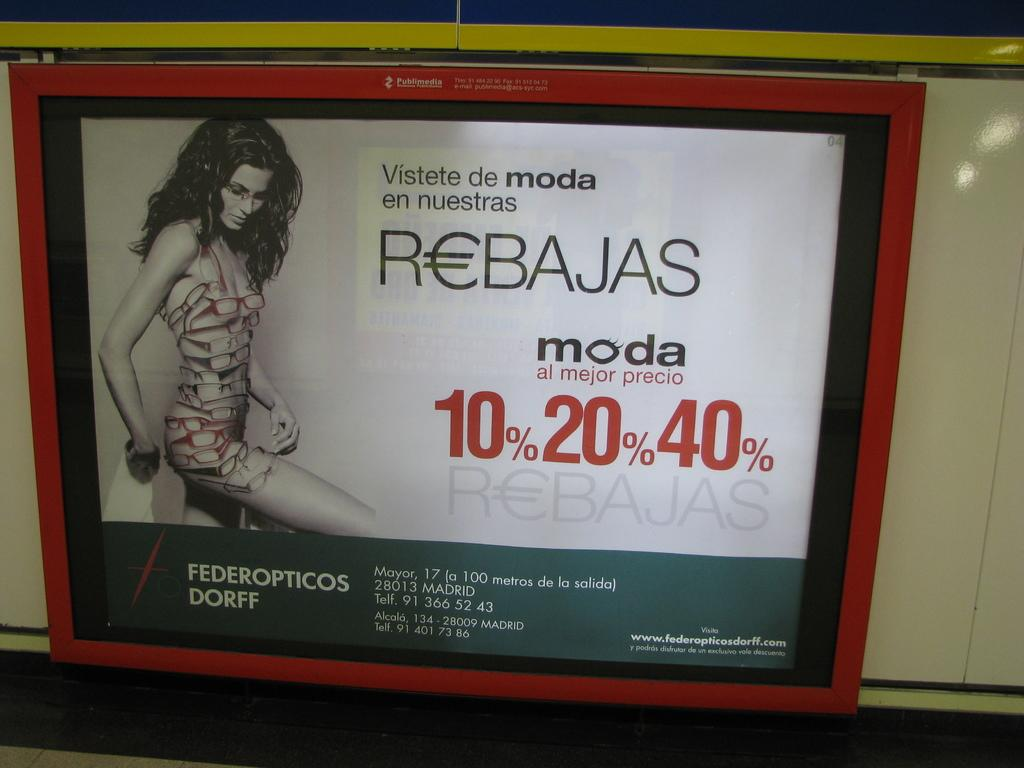What is the main object in the image? There is a board in the image. What is happening with the board in the image? A person is standing on the board. What can be seen on the board? There is writing on the board. What is the board attached to in the image? The board is attached to a white color surface. What type of arch can be seen in the background of the image? There is no arch present in the image; it only features a board, a person standing on it, writing on the board, and the board's attachment to a white color surface. 